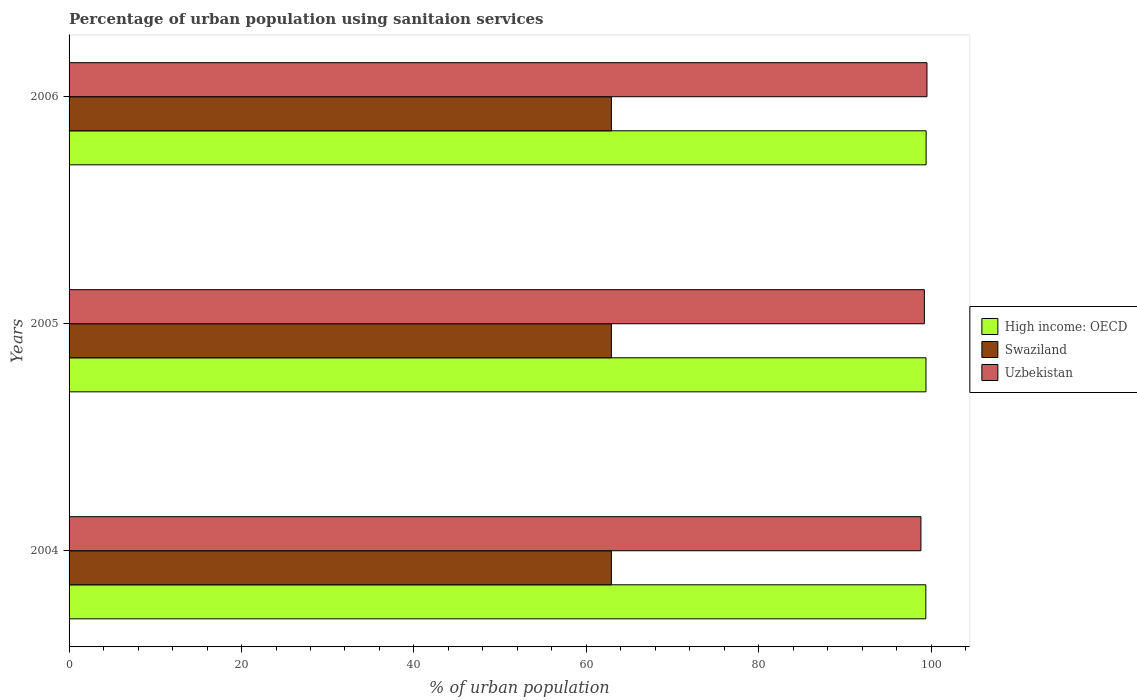How many groups of bars are there?
Offer a terse response. 3. Are the number of bars per tick equal to the number of legend labels?
Ensure brevity in your answer.  Yes. How many bars are there on the 2nd tick from the top?
Your response must be concise. 3. How many bars are there on the 1st tick from the bottom?
Your answer should be very brief. 3. What is the label of the 1st group of bars from the top?
Your answer should be compact. 2006. What is the percentage of urban population using sanitaion services in High income: OECD in 2004?
Provide a succinct answer. 99.37. Across all years, what is the maximum percentage of urban population using sanitaion services in Swaziland?
Offer a very short reply. 62.9. Across all years, what is the minimum percentage of urban population using sanitaion services in High income: OECD?
Ensure brevity in your answer.  99.37. In which year was the percentage of urban population using sanitaion services in Swaziland maximum?
Ensure brevity in your answer.  2004. What is the total percentage of urban population using sanitaion services in Uzbekistan in the graph?
Provide a short and direct response. 297.5. What is the difference between the percentage of urban population using sanitaion services in High income: OECD in 2004 and that in 2006?
Offer a terse response. -0.04. What is the difference between the percentage of urban population using sanitaion services in High income: OECD in 2004 and the percentage of urban population using sanitaion services in Uzbekistan in 2005?
Your answer should be very brief. 0.17. What is the average percentage of urban population using sanitaion services in Uzbekistan per year?
Your answer should be very brief. 99.17. In the year 2004, what is the difference between the percentage of urban population using sanitaion services in High income: OECD and percentage of urban population using sanitaion services in Uzbekistan?
Give a very brief answer. 0.57. In how many years, is the percentage of urban population using sanitaion services in Swaziland greater than 4 %?
Your response must be concise. 3. What is the ratio of the percentage of urban population using sanitaion services in High income: OECD in 2005 to that in 2006?
Keep it short and to the point. 1. Is the percentage of urban population using sanitaion services in High income: OECD in 2004 less than that in 2005?
Your answer should be compact. Yes. What is the difference between the highest and the second highest percentage of urban population using sanitaion services in High income: OECD?
Give a very brief answer. 0.02. What is the difference between the highest and the lowest percentage of urban population using sanitaion services in High income: OECD?
Ensure brevity in your answer.  0.04. Is the sum of the percentage of urban population using sanitaion services in Swaziland in 2004 and 2005 greater than the maximum percentage of urban population using sanitaion services in High income: OECD across all years?
Offer a terse response. Yes. What does the 3rd bar from the top in 2005 represents?
Your answer should be compact. High income: OECD. What does the 1st bar from the bottom in 2006 represents?
Keep it short and to the point. High income: OECD. How many bars are there?
Your response must be concise. 9. Are all the bars in the graph horizontal?
Offer a very short reply. Yes. How many years are there in the graph?
Provide a short and direct response. 3. What is the difference between two consecutive major ticks on the X-axis?
Offer a very short reply. 20. Does the graph contain any zero values?
Keep it short and to the point. No. Does the graph contain grids?
Keep it short and to the point. No. How many legend labels are there?
Your response must be concise. 3. What is the title of the graph?
Provide a succinct answer. Percentage of urban population using sanitaion services. Does "Greece" appear as one of the legend labels in the graph?
Your answer should be very brief. No. What is the label or title of the X-axis?
Give a very brief answer. % of urban population. What is the label or title of the Y-axis?
Give a very brief answer. Years. What is the % of urban population in High income: OECD in 2004?
Provide a succinct answer. 99.37. What is the % of urban population in Swaziland in 2004?
Give a very brief answer. 62.9. What is the % of urban population in Uzbekistan in 2004?
Give a very brief answer. 98.8. What is the % of urban population of High income: OECD in 2005?
Keep it short and to the point. 99.39. What is the % of urban population of Swaziland in 2005?
Ensure brevity in your answer.  62.9. What is the % of urban population of Uzbekistan in 2005?
Offer a terse response. 99.2. What is the % of urban population in High income: OECD in 2006?
Offer a terse response. 99.4. What is the % of urban population of Swaziland in 2006?
Your answer should be compact. 62.9. What is the % of urban population in Uzbekistan in 2006?
Offer a terse response. 99.5. Across all years, what is the maximum % of urban population of High income: OECD?
Make the answer very short. 99.4. Across all years, what is the maximum % of urban population in Swaziland?
Provide a succinct answer. 62.9. Across all years, what is the maximum % of urban population in Uzbekistan?
Your response must be concise. 99.5. Across all years, what is the minimum % of urban population of High income: OECD?
Give a very brief answer. 99.37. Across all years, what is the minimum % of urban population of Swaziland?
Give a very brief answer. 62.9. Across all years, what is the minimum % of urban population in Uzbekistan?
Ensure brevity in your answer.  98.8. What is the total % of urban population of High income: OECD in the graph?
Make the answer very short. 298.16. What is the total % of urban population in Swaziland in the graph?
Make the answer very short. 188.7. What is the total % of urban population of Uzbekistan in the graph?
Make the answer very short. 297.5. What is the difference between the % of urban population of High income: OECD in 2004 and that in 2005?
Give a very brief answer. -0.02. What is the difference between the % of urban population of Uzbekistan in 2004 and that in 2005?
Your answer should be very brief. -0.4. What is the difference between the % of urban population of High income: OECD in 2004 and that in 2006?
Offer a very short reply. -0.04. What is the difference between the % of urban population in Swaziland in 2004 and that in 2006?
Offer a very short reply. 0. What is the difference between the % of urban population of High income: OECD in 2005 and that in 2006?
Ensure brevity in your answer.  -0.02. What is the difference between the % of urban population in Swaziland in 2005 and that in 2006?
Provide a short and direct response. 0. What is the difference between the % of urban population of High income: OECD in 2004 and the % of urban population of Swaziland in 2005?
Your answer should be compact. 36.47. What is the difference between the % of urban population of High income: OECD in 2004 and the % of urban population of Uzbekistan in 2005?
Your response must be concise. 0.17. What is the difference between the % of urban population in Swaziland in 2004 and the % of urban population in Uzbekistan in 2005?
Make the answer very short. -36.3. What is the difference between the % of urban population in High income: OECD in 2004 and the % of urban population in Swaziland in 2006?
Your response must be concise. 36.47. What is the difference between the % of urban population of High income: OECD in 2004 and the % of urban population of Uzbekistan in 2006?
Keep it short and to the point. -0.13. What is the difference between the % of urban population in Swaziland in 2004 and the % of urban population in Uzbekistan in 2006?
Offer a very short reply. -36.6. What is the difference between the % of urban population of High income: OECD in 2005 and the % of urban population of Swaziland in 2006?
Your answer should be compact. 36.49. What is the difference between the % of urban population in High income: OECD in 2005 and the % of urban population in Uzbekistan in 2006?
Make the answer very short. -0.11. What is the difference between the % of urban population in Swaziland in 2005 and the % of urban population in Uzbekistan in 2006?
Offer a very short reply. -36.6. What is the average % of urban population in High income: OECD per year?
Provide a succinct answer. 99.39. What is the average % of urban population in Swaziland per year?
Provide a succinct answer. 62.9. What is the average % of urban population in Uzbekistan per year?
Your response must be concise. 99.17. In the year 2004, what is the difference between the % of urban population in High income: OECD and % of urban population in Swaziland?
Provide a short and direct response. 36.47. In the year 2004, what is the difference between the % of urban population in High income: OECD and % of urban population in Uzbekistan?
Your response must be concise. 0.57. In the year 2004, what is the difference between the % of urban population in Swaziland and % of urban population in Uzbekistan?
Give a very brief answer. -35.9. In the year 2005, what is the difference between the % of urban population in High income: OECD and % of urban population in Swaziland?
Offer a terse response. 36.49. In the year 2005, what is the difference between the % of urban population in High income: OECD and % of urban population in Uzbekistan?
Give a very brief answer. 0.19. In the year 2005, what is the difference between the % of urban population of Swaziland and % of urban population of Uzbekistan?
Keep it short and to the point. -36.3. In the year 2006, what is the difference between the % of urban population in High income: OECD and % of urban population in Swaziland?
Provide a succinct answer. 36.5. In the year 2006, what is the difference between the % of urban population in High income: OECD and % of urban population in Uzbekistan?
Your answer should be very brief. -0.1. In the year 2006, what is the difference between the % of urban population in Swaziland and % of urban population in Uzbekistan?
Make the answer very short. -36.6. What is the ratio of the % of urban population in High income: OECD in 2004 to that in 2005?
Provide a succinct answer. 1. What is the ratio of the % of urban population of Swaziland in 2004 to that in 2005?
Give a very brief answer. 1. What is the ratio of the % of urban population in High income: OECD in 2005 to that in 2006?
Your response must be concise. 1. What is the difference between the highest and the second highest % of urban population in High income: OECD?
Offer a very short reply. 0.02. What is the difference between the highest and the second highest % of urban population in Swaziland?
Keep it short and to the point. 0. What is the difference between the highest and the lowest % of urban population of High income: OECD?
Offer a terse response. 0.04. What is the difference between the highest and the lowest % of urban population of Swaziland?
Make the answer very short. 0. What is the difference between the highest and the lowest % of urban population of Uzbekistan?
Your answer should be compact. 0.7. 